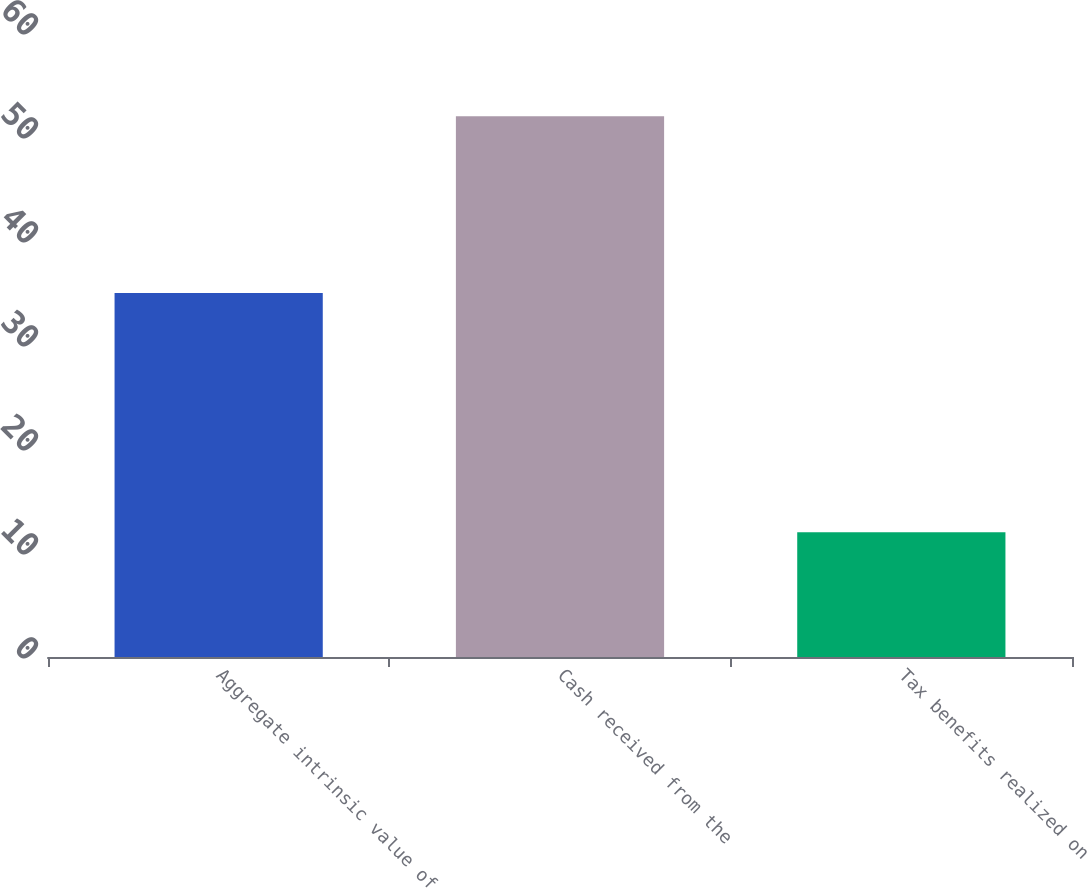Convert chart to OTSL. <chart><loc_0><loc_0><loc_500><loc_500><bar_chart><fcel>Aggregate intrinsic value of<fcel>Cash received from the<fcel>Tax benefits realized on<nl><fcel>35<fcel>52<fcel>12<nl></chart> 